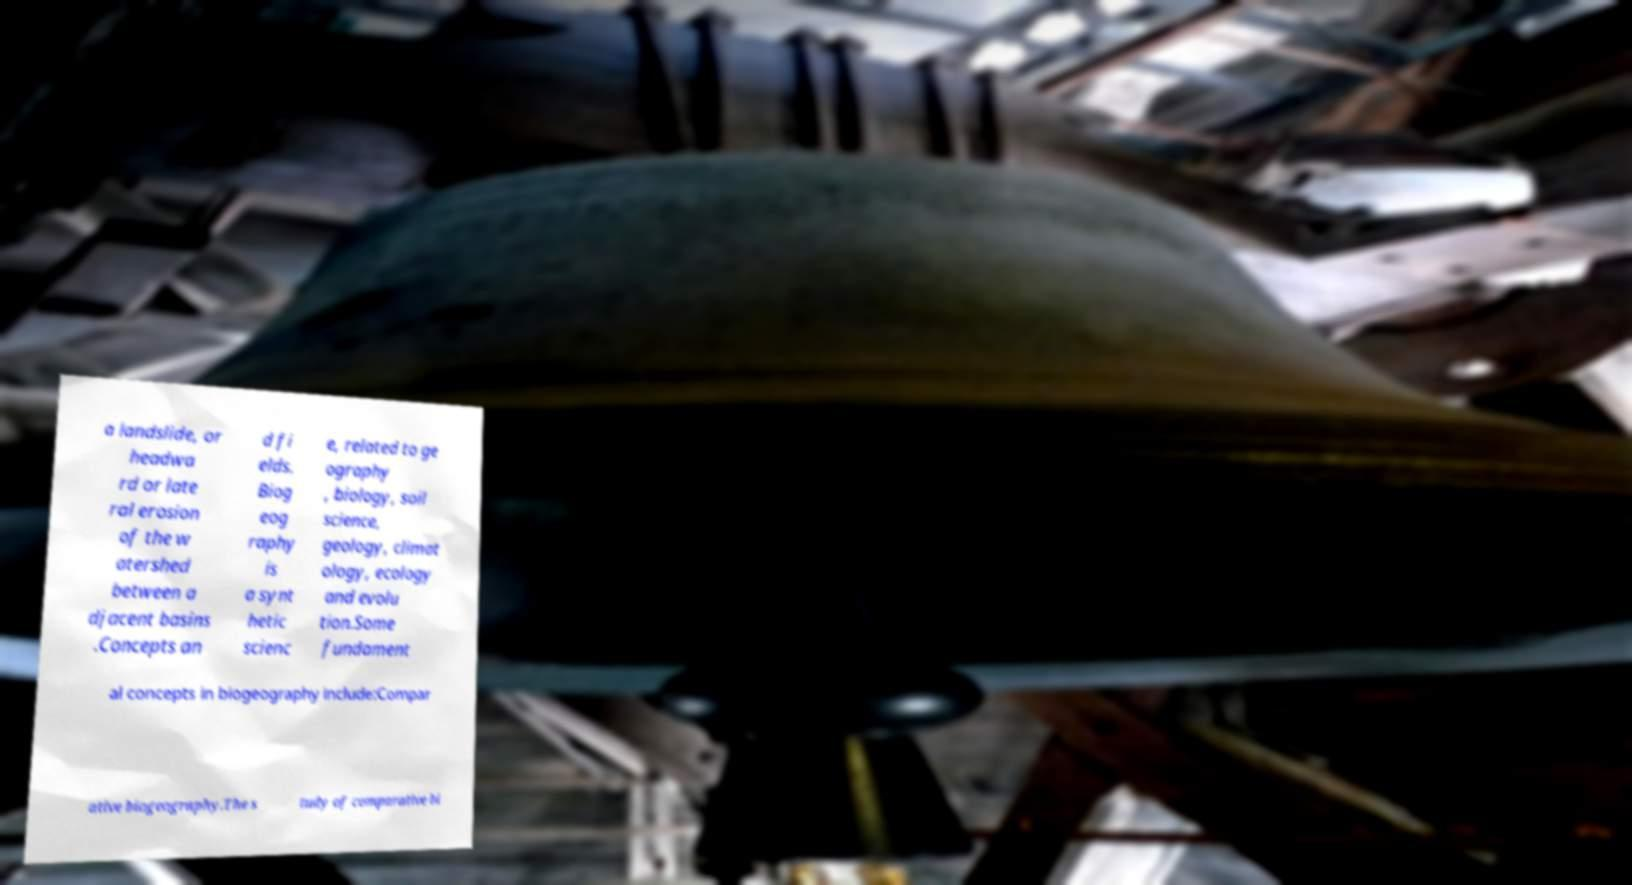What messages or text are displayed in this image? I need them in a readable, typed format. a landslide, or headwa rd or late ral erosion of the w atershed between a djacent basins .Concepts an d fi elds. Biog eog raphy is a synt hetic scienc e, related to ge ography , biology, soil science, geology, climat ology, ecology and evolu tion.Some fundament al concepts in biogeography include:Compar ative biogeography.The s tudy of comparative bi 